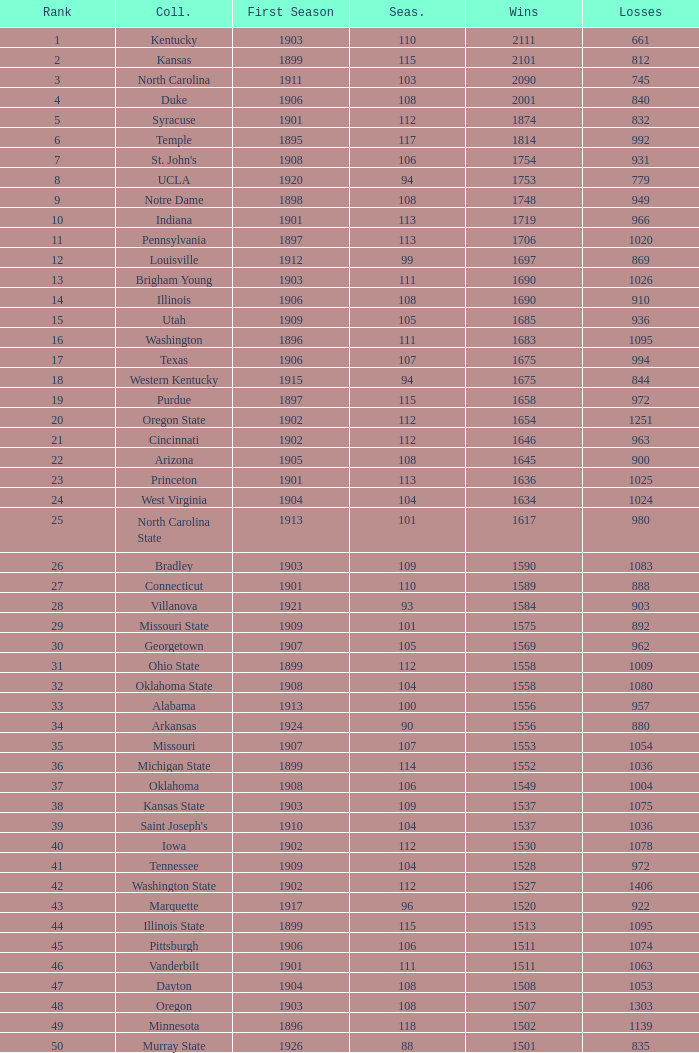What is the total number of rank with losses less than 992, North Carolina State College and a season greater than 101? 0.0. 